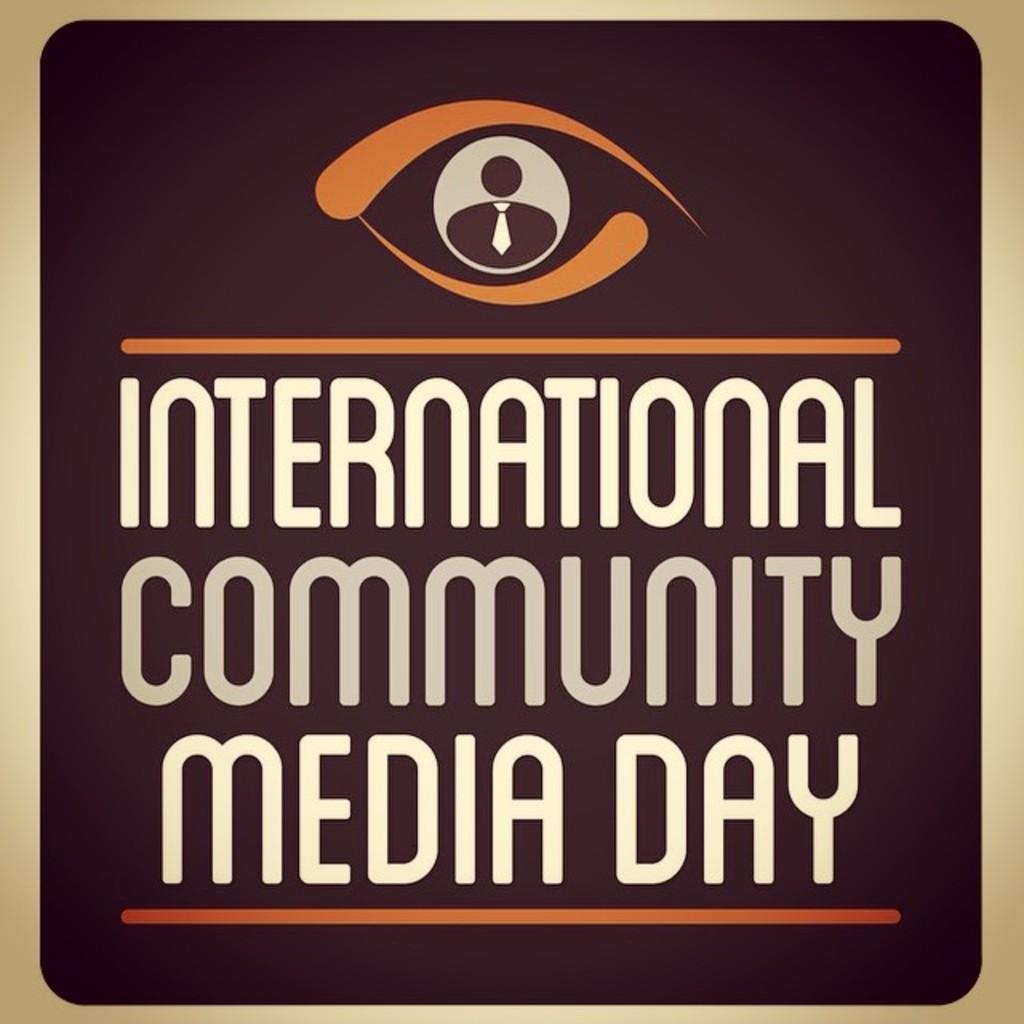<image>
Offer a succinct explanation of the picture presented. a brown and beige sign taht reads international community media day. 